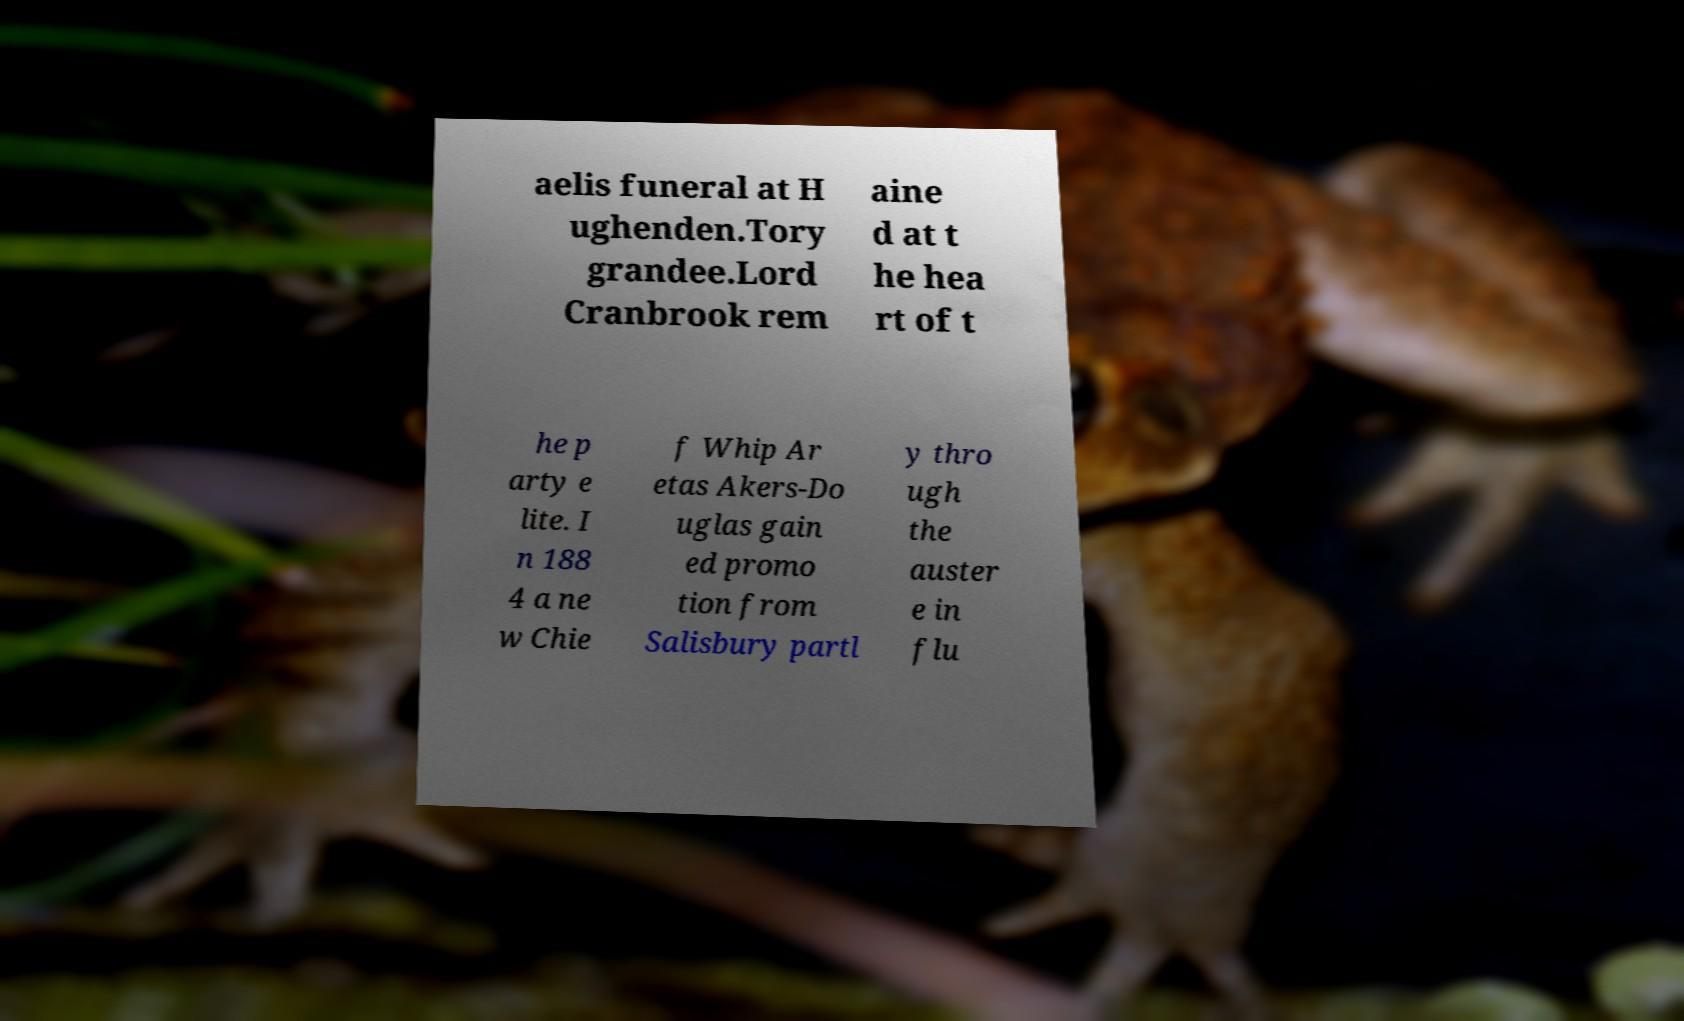For documentation purposes, I need the text within this image transcribed. Could you provide that? aelis funeral at H ughenden.Tory grandee.Lord Cranbrook rem aine d at t he hea rt of t he p arty e lite. I n 188 4 a ne w Chie f Whip Ar etas Akers-Do uglas gain ed promo tion from Salisbury partl y thro ugh the auster e in flu 